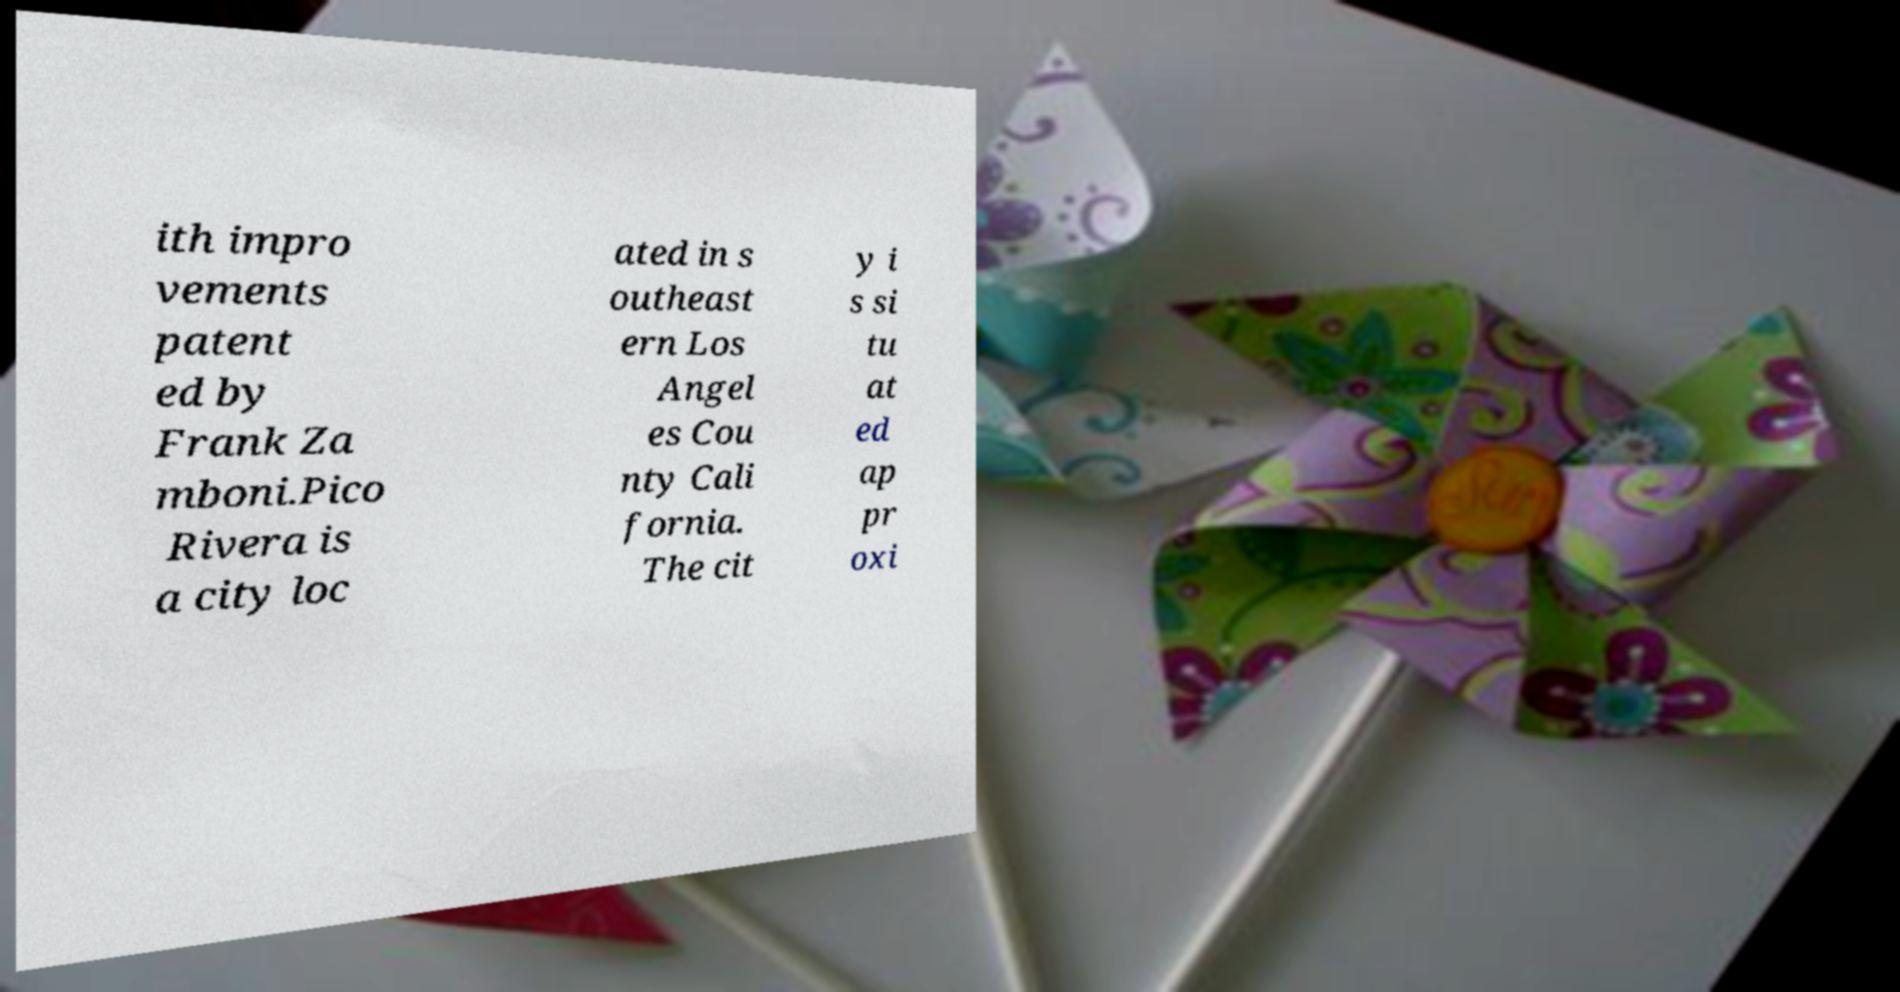There's text embedded in this image that I need extracted. Can you transcribe it verbatim? ith impro vements patent ed by Frank Za mboni.Pico Rivera is a city loc ated in s outheast ern Los Angel es Cou nty Cali fornia. The cit y i s si tu at ed ap pr oxi 